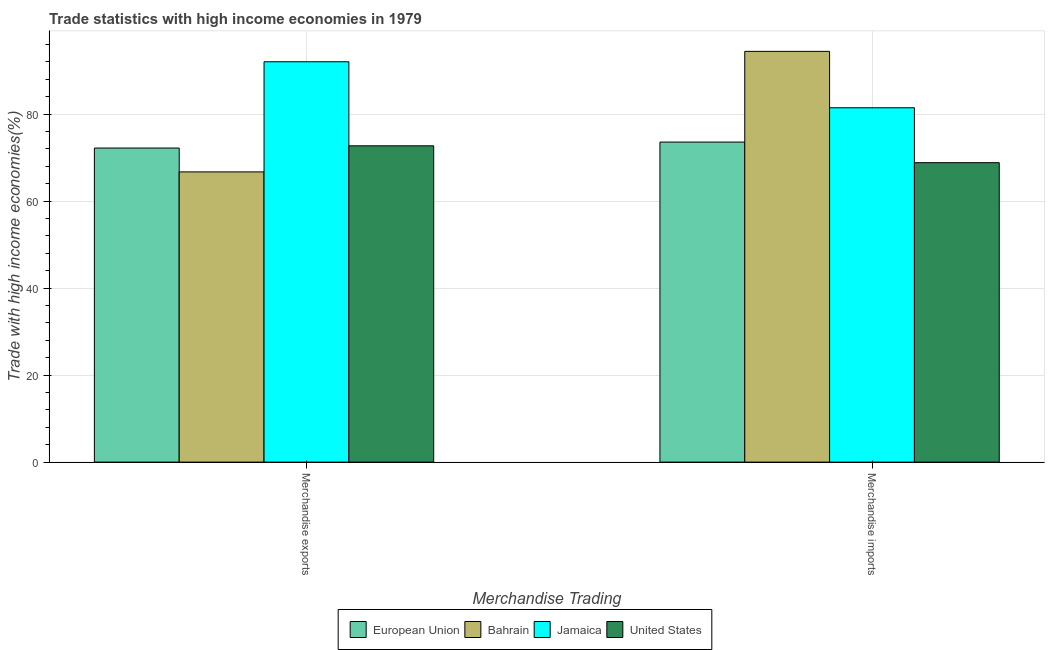Are the number of bars per tick equal to the number of legend labels?
Your answer should be very brief. Yes. How many bars are there on the 1st tick from the left?
Your answer should be compact. 4. What is the label of the 1st group of bars from the left?
Provide a short and direct response. Merchandise exports. What is the merchandise imports in Bahrain?
Make the answer very short. 94.4. Across all countries, what is the maximum merchandise imports?
Provide a succinct answer. 94.4. Across all countries, what is the minimum merchandise exports?
Offer a very short reply. 66.7. In which country was the merchandise exports maximum?
Your answer should be compact. Jamaica. What is the total merchandise exports in the graph?
Your answer should be compact. 303.59. What is the difference between the merchandise exports in Jamaica and that in Bahrain?
Provide a succinct answer. 25.31. What is the difference between the merchandise exports in Jamaica and the merchandise imports in Bahrain?
Provide a short and direct response. -2.39. What is the average merchandise exports per country?
Provide a succinct answer. 75.9. What is the difference between the merchandise exports and merchandise imports in Bahrain?
Keep it short and to the point. -27.7. What is the ratio of the merchandise imports in United States to that in Jamaica?
Provide a succinct answer. 0.85. Is the merchandise exports in Bahrain less than that in United States?
Your response must be concise. Yes. In how many countries, is the merchandise imports greater than the average merchandise imports taken over all countries?
Your answer should be compact. 2. What does the 3rd bar from the left in Merchandise exports represents?
Your response must be concise. Jamaica. What does the 2nd bar from the right in Merchandise imports represents?
Your answer should be very brief. Jamaica. How many bars are there?
Offer a terse response. 8. How many countries are there in the graph?
Ensure brevity in your answer.  4. Are the values on the major ticks of Y-axis written in scientific E-notation?
Keep it short and to the point. No. Where does the legend appear in the graph?
Make the answer very short. Bottom center. How many legend labels are there?
Provide a succinct answer. 4. What is the title of the graph?
Provide a short and direct response. Trade statistics with high income economies in 1979. Does "Andorra" appear as one of the legend labels in the graph?
Your answer should be very brief. No. What is the label or title of the X-axis?
Provide a succinct answer. Merchandise Trading. What is the label or title of the Y-axis?
Give a very brief answer. Trade with high income economies(%). What is the Trade with high income economies(%) in European Union in Merchandise exports?
Give a very brief answer. 72.18. What is the Trade with high income economies(%) in Bahrain in Merchandise exports?
Keep it short and to the point. 66.7. What is the Trade with high income economies(%) of Jamaica in Merchandise exports?
Give a very brief answer. 92.01. What is the Trade with high income economies(%) of United States in Merchandise exports?
Offer a terse response. 72.69. What is the Trade with high income economies(%) in European Union in Merchandise imports?
Your response must be concise. 73.55. What is the Trade with high income economies(%) in Bahrain in Merchandise imports?
Your answer should be compact. 94.4. What is the Trade with high income economies(%) in Jamaica in Merchandise imports?
Provide a succinct answer. 81.44. What is the Trade with high income economies(%) of United States in Merchandise imports?
Give a very brief answer. 68.82. Across all Merchandise Trading, what is the maximum Trade with high income economies(%) in European Union?
Give a very brief answer. 73.55. Across all Merchandise Trading, what is the maximum Trade with high income economies(%) of Bahrain?
Offer a very short reply. 94.4. Across all Merchandise Trading, what is the maximum Trade with high income economies(%) of Jamaica?
Offer a terse response. 92.01. Across all Merchandise Trading, what is the maximum Trade with high income economies(%) of United States?
Your answer should be compact. 72.69. Across all Merchandise Trading, what is the minimum Trade with high income economies(%) of European Union?
Offer a very short reply. 72.18. Across all Merchandise Trading, what is the minimum Trade with high income economies(%) in Bahrain?
Make the answer very short. 66.7. Across all Merchandise Trading, what is the minimum Trade with high income economies(%) in Jamaica?
Give a very brief answer. 81.44. Across all Merchandise Trading, what is the minimum Trade with high income economies(%) in United States?
Your response must be concise. 68.82. What is the total Trade with high income economies(%) of European Union in the graph?
Ensure brevity in your answer.  145.74. What is the total Trade with high income economies(%) in Bahrain in the graph?
Your response must be concise. 161.1. What is the total Trade with high income economies(%) of Jamaica in the graph?
Offer a terse response. 173.45. What is the total Trade with high income economies(%) of United States in the graph?
Keep it short and to the point. 141.51. What is the difference between the Trade with high income economies(%) of European Union in Merchandise exports and that in Merchandise imports?
Keep it short and to the point. -1.37. What is the difference between the Trade with high income economies(%) in Bahrain in Merchandise exports and that in Merchandise imports?
Your answer should be very brief. -27.7. What is the difference between the Trade with high income economies(%) in Jamaica in Merchandise exports and that in Merchandise imports?
Provide a short and direct response. 10.57. What is the difference between the Trade with high income economies(%) in United States in Merchandise exports and that in Merchandise imports?
Provide a short and direct response. 3.87. What is the difference between the Trade with high income economies(%) of European Union in Merchandise exports and the Trade with high income economies(%) of Bahrain in Merchandise imports?
Your answer should be compact. -22.22. What is the difference between the Trade with high income economies(%) of European Union in Merchandise exports and the Trade with high income economies(%) of Jamaica in Merchandise imports?
Make the answer very short. -9.26. What is the difference between the Trade with high income economies(%) of European Union in Merchandise exports and the Trade with high income economies(%) of United States in Merchandise imports?
Offer a terse response. 3.36. What is the difference between the Trade with high income economies(%) of Bahrain in Merchandise exports and the Trade with high income economies(%) of Jamaica in Merchandise imports?
Give a very brief answer. -14.74. What is the difference between the Trade with high income economies(%) in Bahrain in Merchandise exports and the Trade with high income economies(%) in United States in Merchandise imports?
Offer a very short reply. -2.12. What is the difference between the Trade with high income economies(%) in Jamaica in Merchandise exports and the Trade with high income economies(%) in United States in Merchandise imports?
Your answer should be compact. 23.19. What is the average Trade with high income economies(%) of European Union per Merchandise Trading?
Your answer should be very brief. 72.87. What is the average Trade with high income economies(%) in Bahrain per Merchandise Trading?
Provide a short and direct response. 80.55. What is the average Trade with high income economies(%) of Jamaica per Merchandise Trading?
Make the answer very short. 86.73. What is the average Trade with high income economies(%) of United States per Merchandise Trading?
Give a very brief answer. 70.76. What is the difference between the Trade with high income economies(%) in European Union and Trade with high income economies(%) in Bahrain in Merchandise exports?
Ensure brevity in your answer.  5.48. What is the difference between the Trade with high income economies(%) of European Union and Trade with high income economies(%) of Jamaica in Merchandise exports?
Provide a short and direct response. -19.83. What is the difference between the Trade with high income economies(%) in European Union and Trade with high income economies(%) in United States in Merchandise exports?
Provide a short and direct response. -0.51. What is the difference between the Trade with high income economies(%) of Bahrain and Trade with high income economies(%) of Jamaica in Merchandise exports?
Give a very brief answer. -25.31. What is the difference between the Trade with high income economies(%) of Bahrain and Trade with high income economies(%) of United States in Merchandise exports?
Provide a succinct answer. -6. What is the difference between the Trade with high income economies(%) in Jamaica and Trade with high income economies(%) in United States in Merchandise exports?
Provide a succinct answer. 19.32. What is the difference between the Trade with high income economies(%) in European Union and Trade with high income economies(%) in Bahrain in Merchandise imports?
Ensure brevity in your answer.  -20.85. What is the difference between the Trade with high income economies(%) in European Union and Trade with high income economies(%) in Jamaica in Merchandise imports?
Ensure brevity in your answer.  -7.89. What is the difference between the Trade with high income economies(%) in European Union and Trade with high income economies(%) in United States in Merchandise imports?
Your answer should be very brief. 4.73. What is the difference between the Trade with high income economies(%) in Bahrain and Trade with high income economies(%) in Jamaica in Merchandise imports?
Your answer should be compact. 12.96. What is the difference between the Trade with high income economies(%) in Bahrain and Trade with high income economies(%) in United States in Merchandise imports?
Make the answer very short. 25.58. What is the difference between the Trade with high income economies(%) in Jamaica and Trade with high income economies(%) in United States in Merchandise imports?
Provide a short and direct response. 12.62. What is the ratio of the Trade with high income economies(%) in European Union in Merchandise exports to that in Merchandise imports?
Your answer should be compact. 0.98. What is the ratio of the Trade with high income economies(%) of Bahrain in Merchandise exports to that in Merchandise imports?
Provide a succinct answer. 0.71. What is the ratio of the Trade with high income economies(%) in Jamaica in Merchandise exports to that in Merchandise imports?
Keep it short and to the point. 1.13. What is the ratio of the Trade with high income economies(%) in United States in Merchandise exports to that in Merchandise imports?
Your response must be concise. 1.06. What is the difference between the highest and the second highest Trade with high income economies(%) of European Union?
Ensure brevity in your answer.  1.37. What is the difference between the highest and the second highest Trade with high income economies(%) of Bahrain?
Provide a succinct answer. 27.7. What is the difference between the highest and the second highest Trade with high income economies(%) in Jamaica?
Offer a terse response. 10.57. What is the difference between the highest and the second highest Trade with high income economies(%) in United States?
Keep it short and to the point. 3.87. What is the difference between the highest and the lowest Trade with high income economies(%) of European Union?
Your answer should be very brief. 1.37. What is the difference between the highest and the lowest Trade with high income economies(%) in Bahrain?
Make the answer very short. 27.7. What is the difference between the highest and the lowest Trade with high income economies(%) in Jamaica?
Your answer should be compact. 10.57. What is the difference between the highest and the lowest Trade with high income economies(%) of United States?
Your answer should be very brief. 3.87. 